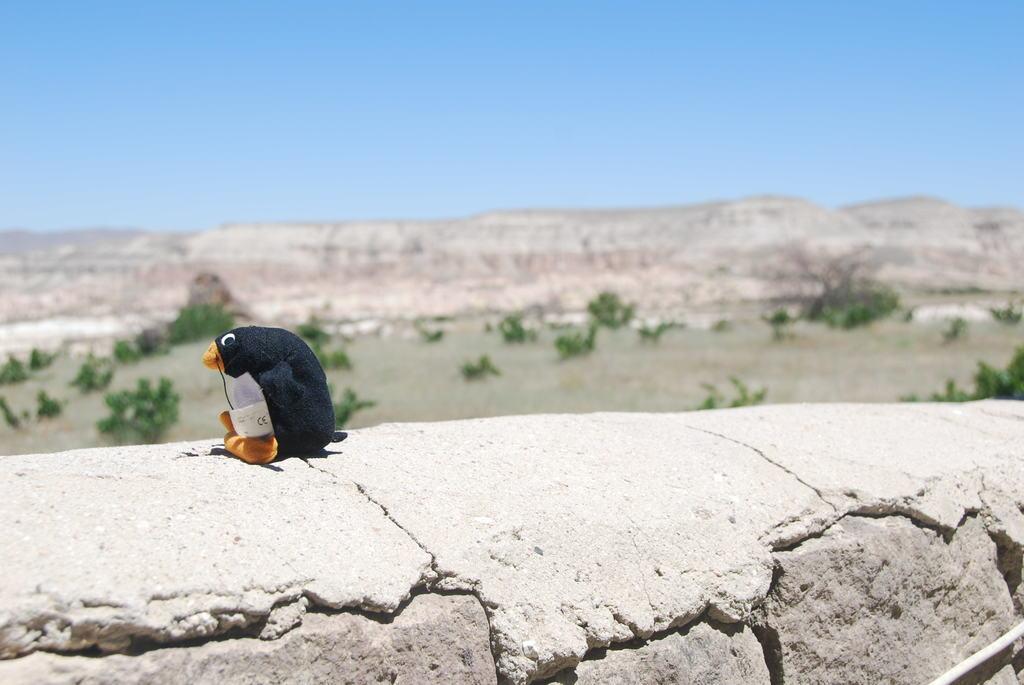Could you give a brief overview of what you see in this image? In this image I can see a toy kept on the wall at the top I can see the sky and the hill and planets visible in the middle 